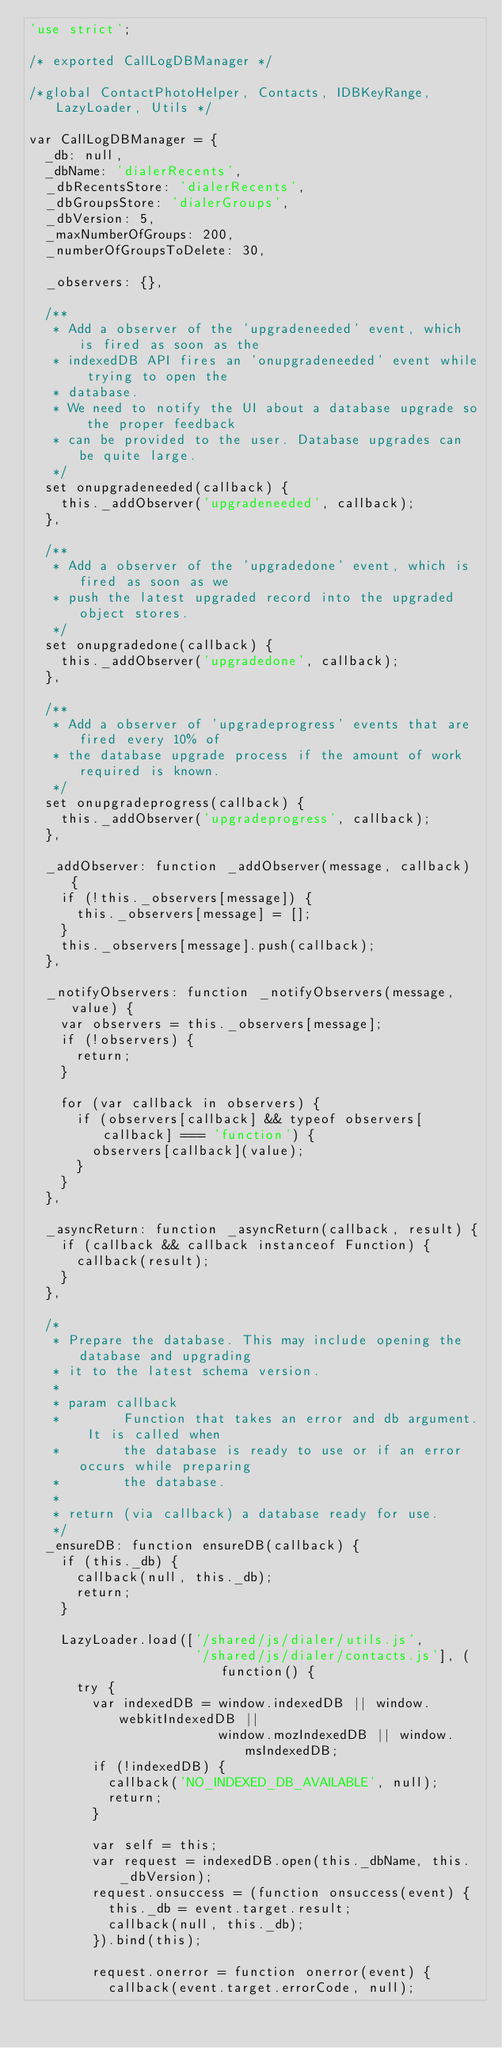Convert code to text. <code><loc_0><loc_0><loc_500><loc_500><_JavaScript_>'use strict';

/* exported CallLogDBManager */

/*global ContactPhotoHelper, Contacts, IDBKeyRange, LazyLoader, Utils */

var CallLogDBManager = {
  _db: null,
  _dbName: 'dialerRecents',
  _dbRecentsStore: 'dialerRecents',
  _dbGroupsStore: 'dialerGroups',
  _dbVersion: 5,
  _maxNumberOfGroups: 200,
  _numberOfGroupsToDelete: 30,

  _observers: {},

  /**
   * Add a observer of the 'upgradeneeded' event, which is fired as soon as the
   * indexedDB API fires an 'onupgradeneeded' event while trying to open the
   * database.
   * We need to notify the UI about a database upgrade so the proper feedback
   * can be provided to the user. Database upgrades can be quite large.
   */
  set onupgradeneeded(callback) {
    this._addObserver('upgradeneeded', callback);
  },

  /**
   * Add a observer of the 'upgradedone' event, which is fired as soon as we
   * push the latest upgraded record into the upgraded object stores.
   */
  set onupgradedone(callback) {
    this._addObserver('upgradedone', callback);
  },

  /**
   * Add a observer of 'upgradeprogress' events that are fired every 10% of
   * the database upgrade process if the amount of work required is known.
   */
  set onupgradeprogress(callback) {
    this._addObserver('upgradeprogress', callback);
  },

  _addObserver: function _addObserver(message, callback) {
    if (!this._observers[message]) {
      this._observers[message] = [];
    }
    this._observers[message].push(callback);
  },

  _notifyObservers: function _notifyObservers(message, value) {
    var observers = this._observers[message];
    if (!observers) {
      return;
    }

    for (var callback in observers) {
      if (observers[callback] && typeof observers[callback] === 'function') {
        observers[callback](value);
      }
    }
  },

  _asyncReturn: function _asyncReturn(callback, result) {
    if (callback && callback instanceof Function) {
      callback(result);
    }
  },

  /*
   * Prepare the database. This may include opening the database and upgrading
   * it to the latest schema version.
   *
   * param callback
   *        Function that takes an error and db argument. It is called when
   *        the database is ready to use or if an error occurs while preparing
   *        the database.
   *
   * return (via callback) a database ready for use.
   */
  _ensureDB: function ensureDB(callback) {
    if (this._db) {
      callback(null, this._db);
      return;
    }

    LazyLoader.load(['/shared/js/dialer/utils.js',
                     '/shared/js/dialer/contacts.js'], (function() {
      try {
        var indexedDB = window.indexedDB || window.webkitIndexedDB ||
                        window.mozIndexedDB || window.msIndexedDB;
        if (!indexedDB) {
          callback('NO_INDEXED_DB_AVAILABLE', null);
          return;
        }

        var self = this;
        var request = indexedDB.open(this._dbName, this._dbVersion);
        request.onsuccess = (function onsuccess(event) {
          this._db = event.target.result;
          callback(null, this._db);
        }).bind(this);

        request.onerror = function onerror(event) {
          callback(event.target.errorCode, null);</code> 